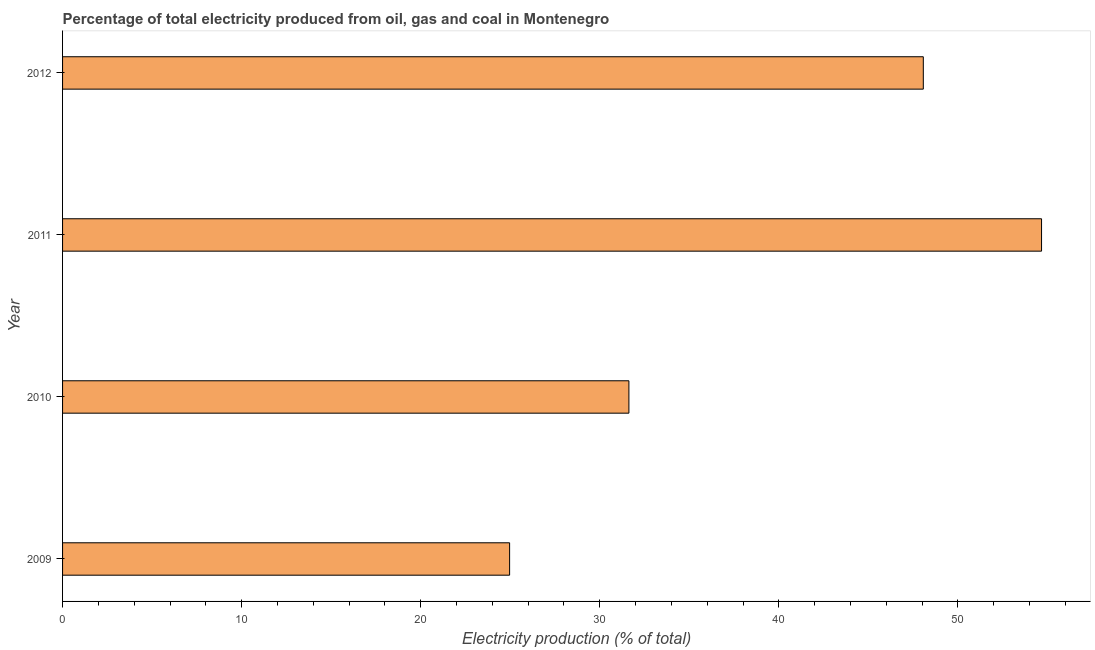Does the graph contain grids?
Offer a terse response. No. What is the title of the graph?
Make the answer very short. Percentage of total electricity produced from oil, gas and coal in Montenegro. What is the label or title of the X-axis?
Your response must be concise. Electricity production (% of total). What is the electricity production in 2010?
Your answer should be very brief. 31.63. Across all years, what is the maximum electricity production?
Ensure brevity in your answer.  54.67. Across all years, what is the minimum electricity production?
Your response must be concise. 24.96. In which year was the electricity production maximum?
Provide a short and direct response. 2011. In which year was the electricity production minimum?
Ensure brevity in your answer.  2009. What is the sum of the electricity production?
Provide a succinct answer. 159.32. What is the difference between the electricity production in 2009 and 2012?
Provide a short and direct response. -23.1. What is the average electricity production per year?
Your response must be concise. 39.83. What is the median electricity production?
Your response must be concise. 39.85. Do a majority of the years between 2010 and 2012 (inclusive) have electricity production greater than 48 %?
Offer a very short reply. Yes. What is the ratio of the electricity production in 2010 to that in 2011?
Give a very brief answer. 0.58. Is the difference between the electricity production in 2009 and 2010 greater than the difference between any two years?
Provide a succinct answer. No. What is the difference between the highest and the second highest electricity production?
Keep it short and to the point. 6.6. Is the sum of the electricity production in 2011 and 2012 greater than the maximum electricity production across all years?
Keep it short and to the point. Yes. What is the difference between the highest and the lowest electricity production?
Offer a very short reply. 29.7. In how many years, is the electricity production greater than the average electricity production taken over all years?
Your response must be concise. 2. Are all the bars in the graph horizontal?
Your answer should be very brief. Yes. What is the Electricity production (% of total) of 2009?
Give a very brief answer. 24.96. What is the Electricity production (% of total) in 2010?
Your answer should be very brief. 31.63. What is the Electricity production (% of total) in 2011?
Your answer should be compact. 54.67. What is the Electricity production (% of total) of 2012?
Your response must be concise. 48.07. What is the difference between the Electricity production (% of total) in 2009 and 2010?
Your answer should be very brief. -6.66. What is the difference between the Electricity production (% of total) in 2009 and 2011?
Your answer should be very brief. -29.7. What is the difference between the Electricity production (% of total) in 2009 and 2012?
Your answer should be compact. -23.1. What is the difference between the Electricity production (% of total) in 2010 and 2011?
Keep it short and to the point. -23.04. What is the difference between the Electricity production (% of total) in 2010 and 2012?
Your response must be concise. -16.44. What is the difference between the Electricity production (% of total) in 2011 and 2012?
Offer a very short reply. 6.6. What is the ratio of the Electricity production (% of total) in 2009 to that in 2010?
Ensure brevity in your answer.  0.79. What is the ratio of the Electricity production (% of total) in 2009 to that in 2011?
Keep it short and to the point. 0.46. What is the ratio of the Electricity production (% of total) in 2009 to that in 2012?
Provide a short and direct response. 0.52. What is the ratio of the Electricity production (% of total) in 2010 to that in 2011?
Offer a very short reply. 0.58. What is the ratio of the Electricity production (% of total) in 2010 to that in 2012?
Your answer should be very brief. 0.66. What is the ratio of the Electricity production (% of total) in 2011 to that in 2012?
Keep it short and to the point. 1.14. 